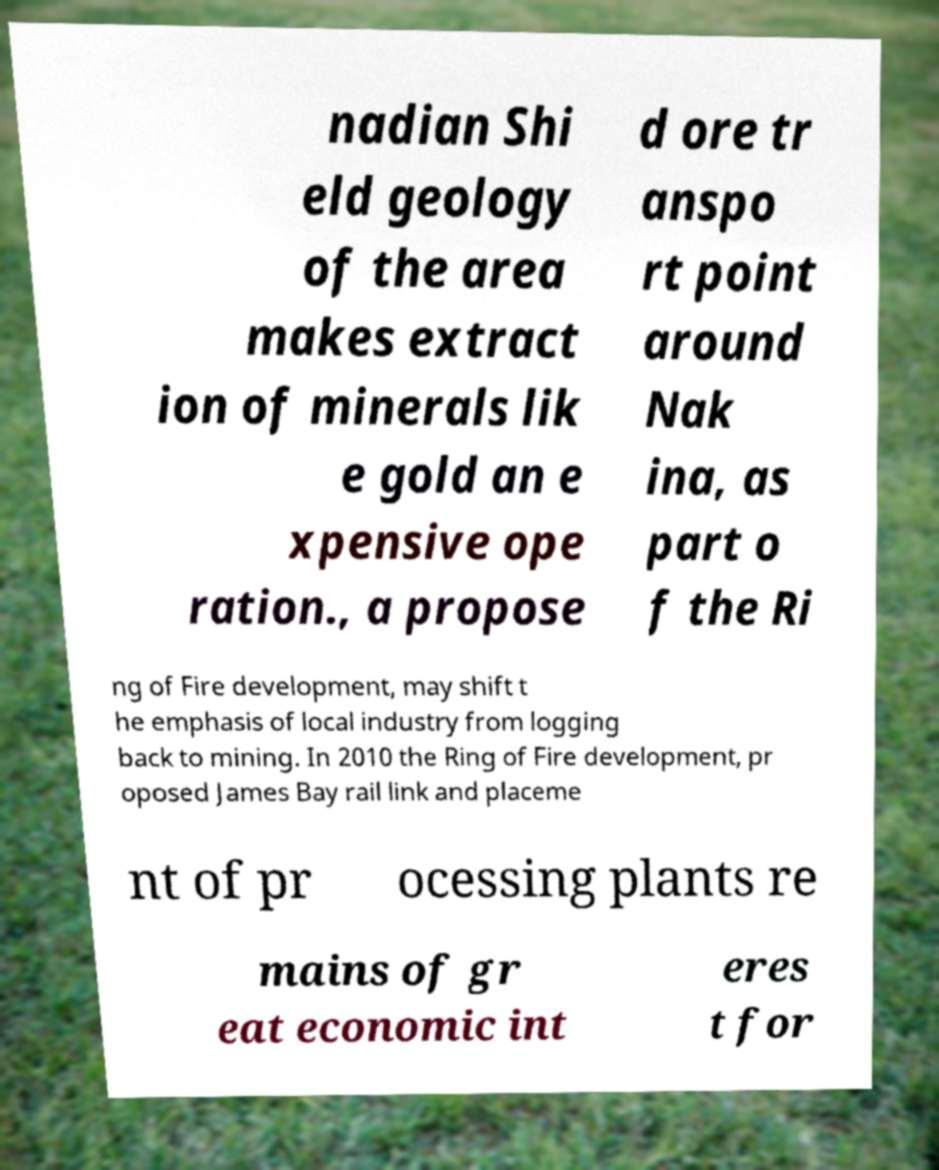Please read and relay the text visible in this image. What does it say? nadian Shi eld geology of the area makes extract ion of minerals lik e gold an e xpensive ope ration., a propose d ore tr anspo rt point around Nak ina, as part o f the Ri ng of Fire development, may shift t he emphasis of local industry from logging back to mining. In 2010 the Ring of Fire development, pr oposed James Bay rail link and placeme nt of pr ocessing plants re mains of gr eat economic int eres t for 